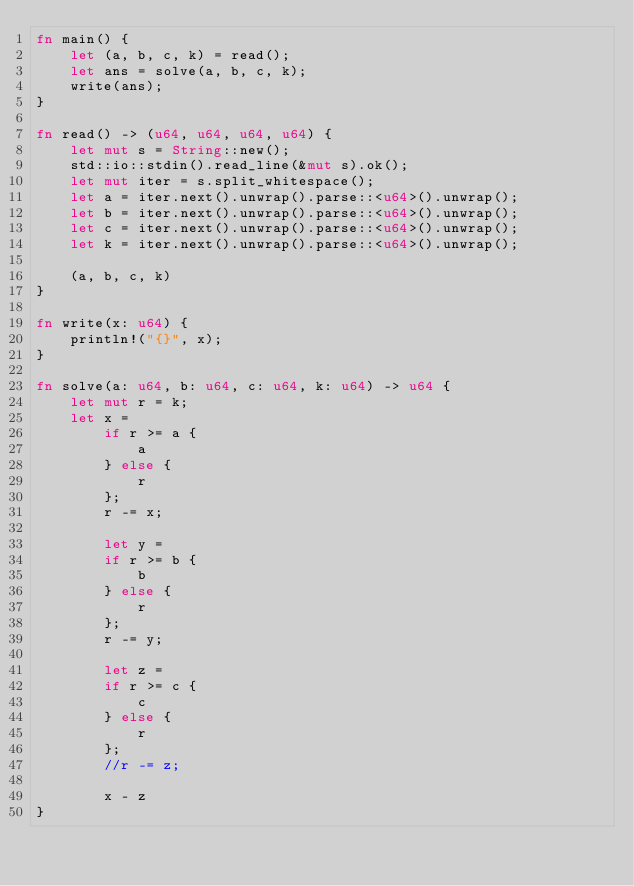Convert code to text. <code><loc_0><loc_0><loc_500><loc_500><_Rust_>fn main() {
    let (a, b, c, k) = read();
    let ans = solve(a, b, c, k);
    write(ans);
}

fn read() -> (u64, u64, u64, u64) {
    let mut s = String::new();
    std::io::stdin().read_line(&mut s).ok();
    let mut iter = s.split_whitespace();
    let a = iter.next().unwrap().parse::<u64>().unwrap();
    let b = iter.next().unwrap().parse::<u64>().unwrap();
    let c = iter.next().unwrap().parse::<u64>().unwrap();
    let k = iter.next().unwrap().parse::<u64>().unwrap();

    (a, b, c, k)
}

fn write(x: u64) {
    println!("{}", x);
}

fn solve(a: u64, b: u64, c: u64, k: u64) -> u64 {
    let mut r = k;
    let x = 
        if r >= a {
            a
        } else {
            r
        };
        r -= x;

        let y =
        if r >= b {
            b
        } else {
            r
        };
        r -= y;
    
        let z =
        if r >= c {
            c
        } else {
            r
        };
        //r -= z;
    
        x - z
}
</code> 